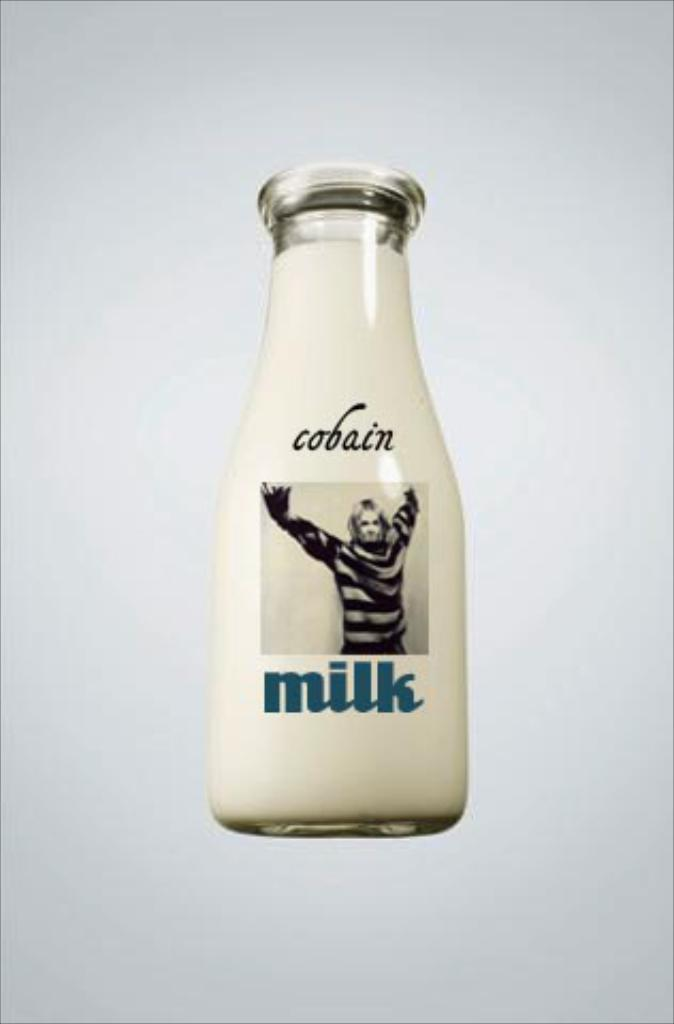What object is present in the image? There is a bottle in the image. What can be found on the bottle? There is text and an image of a person on the bottle. What is the color of the background in the image? The background of the image is white. Can you tell me how many kitties are playing with silk in the image? There are no kitties or silk present in the image; it only features a bottle with text and an image of a person. 